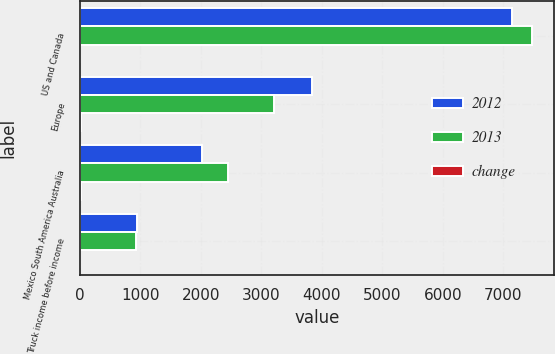Convert chart. <chart><loc_0><loc_0><loc_500><loc_500><stacked_bar_chart><ecel><fcel>US and Canada<fcel>Europe<fcel>Mexico South America Australia<fcel>Truck income before income<nl><fcel>2012<fcel>7138.1<fcel>3844.4<fcel>2020.4<fcel>936.7<nl><fcel>2013<fcel>7467.8<fcel>3217.1<fcel>2446.6<fcel>920.4<nl><fcel>change<fcel>4<fcel>19<fcel>17<fcel>2<nl></chart> 